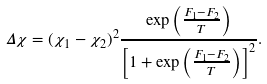Convert formula to latex. <formula><loc_0><loc_0><loc_500><loc_500>\Delta \chi = ( \chi _ { 1 } - \chi _ { 2 } ) ^ { 2 } \frac { \exp \left ( \frac { F _ { 1 } - F _ { 2 } } { T } \right ) } { \left [ 1 + \exp \left ( \frac { F _ { 1 } - F _ { 2 } } { T } \right ) \right ] ^ { 2 } } .</formula> 